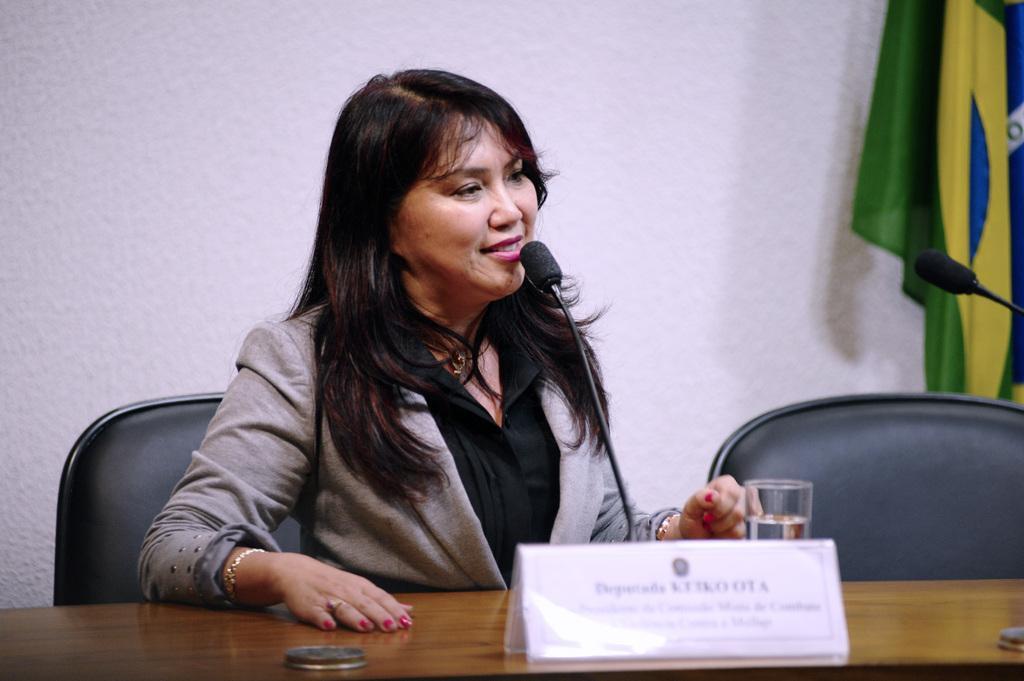In one or two sentences, can you explain what this image depicts? In the middle of the image we can see a woman, she is seated on the chair, in front of her we can see a glass, microphone and a name board on the table, in the background we can see a flag. 